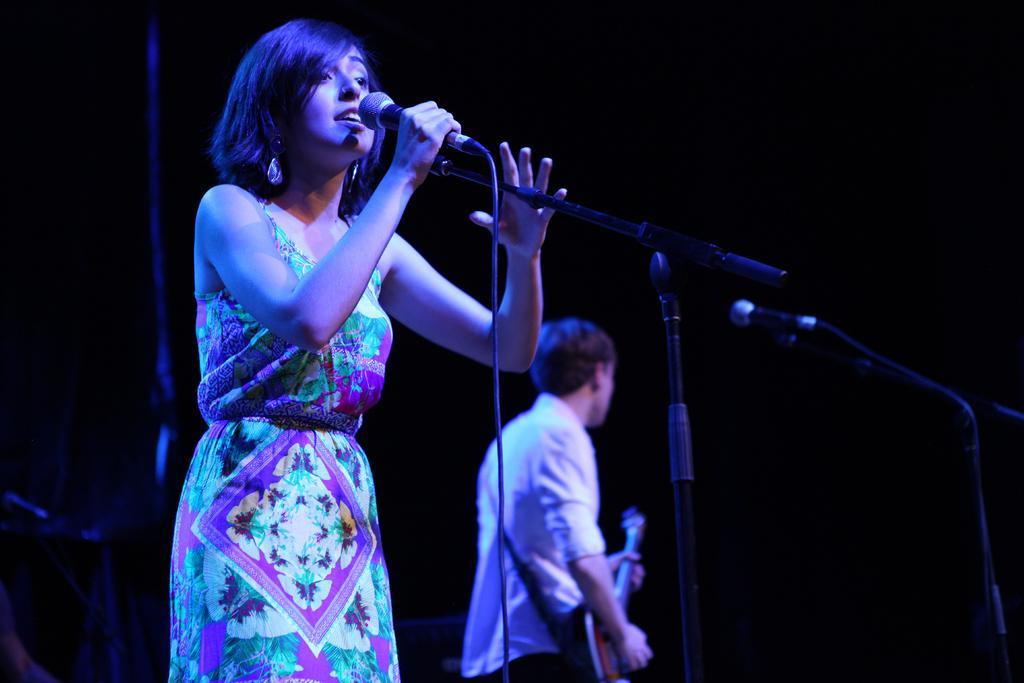Please provide a concise description of this image. In this image we can see two persons standing. One woman is holding a microphone in her hand. One person is holding a guitar in his hands. To the right side of the image we can see a microphone placed on a stand. 